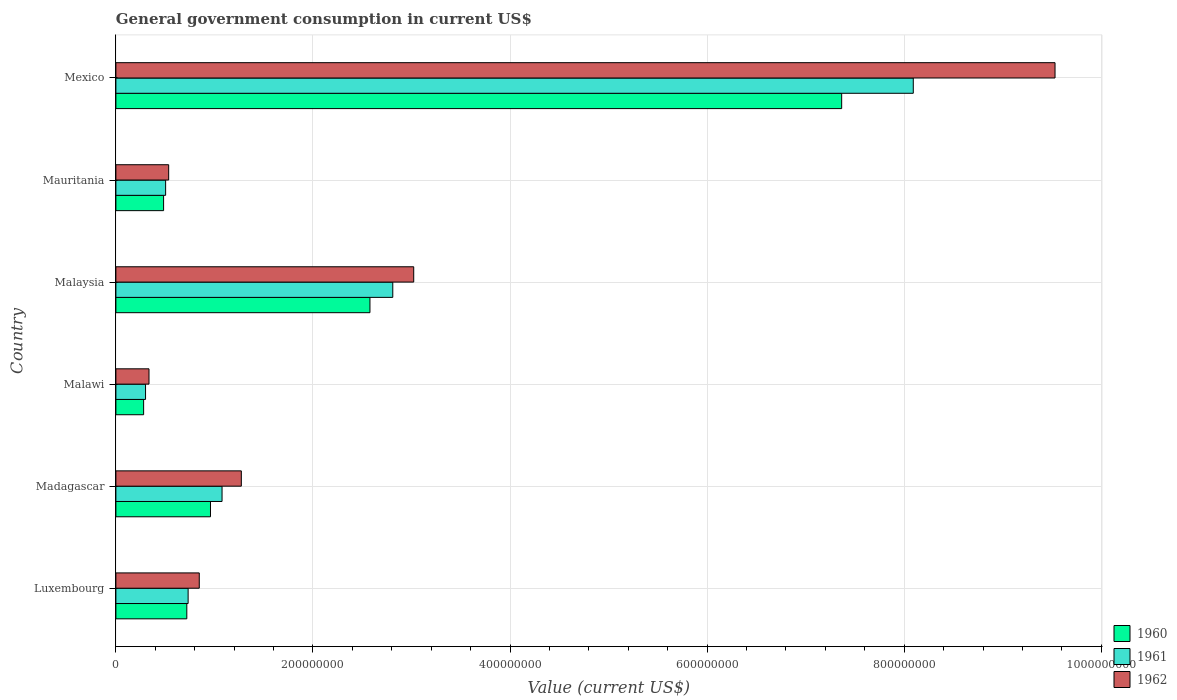How many different coloured bars are there?
Make the answer very short. 3. How many groups of bars are there?
Ensure brevity in your answer.  6. How many bars are there on the 2nd tick from the bottom?
Offer a terse response. 3. What is the label of the 5th group of bars from the top?
Offer a very short reply. Madagascar. In how many cases, is the number of bars for a given country not equal to the number of legend labels?
Your answer should be very brief. 0. What is the government conusmption in 1960 in Mexico?
Offer a terse response. 7.37e+08. Across all countries, what is the maximum government conusmption in 1962?
Your answer should be very brief. 9.53e+08. Across all countries, what is the minimum government conusmption in 1961?
Provide a short and direct response. 3.01e+07. In which country was the government conusmption in 1961 minimum?
Keep it short and to the point. Malawi. What is the total government conusmption in 1962 in the graph?
Offer a terse response. 1.55e+09. What is the difference between the government conusmption in 1961 in Malawi and that in Mexico?
Offer a terse response. -7.79e+08. What is the difference between the government conusmption in 1961 in Malaysia and the government conusmption in 1962 in Mexico?
Offer a terse response. -6.72e+08. What is the average government conusmption in 1961 per country?
Your answer should be very brief. 2.25e+08. What is the difference between the government conusmption in 1960 and government conusmption in 1962 in Mexico?
Your answer should be compact. -2.17e+08. What is the ratio of the government conusmption in 1962 in Luxembourg to that in Malawi?
Offer a terse response. 2.52. Is the government conusmption in 1962 in Luxembourg less than that in Madagascar?
Keep it short and to the point. Yes. Is the difference between the government conusmption in 1960 in Luxembourg and Malaysia greater than the difference between the government conusmption in 1962 in Luxembourg and Malaysia?
Offer a very short reply. Yes. What is the difference between the highest and the second highest government conusmption in 1962?
Give a very brief answer. 6.51e+08. What is the difference between the highest and the lowest government conusmption in 1961?
Provide a succinct answer. 7.79e+08. What does the 2nd bar from the top in Malawi represents?
Offer a terse response. 1961. Is it the case that in every country, the sum of the government conusmption in 1961 and government conusmption in 1960 is greater than the government conusmption in 1962?
Make the answer very short. Yes. How many bars are there?
Your answer should be compact. 18. How many countries are there in the graph?
Keep it short and to the point. 6. What is the difference between two consecutive major ticks on the X-axis?
Ensure brevity in your answer.  2.00e+08. Are the values on the major ticks of X-axis written in scientific E-notation?
Offer a very short reply. No. Does the graph contain any zero values?
Give a very brief answer. No. Where does the legend appear in the graph?
Offer a terse response. Bottom right. How are the legend labels stacked?
Offer a very short reply. Vertical. What is the title of the graph?
Keep it short and to the point. General government consumption in current US$. Does "1977" appear as one of the legend labels in the graph?
Your response must be concise. No. What is the label or title of the X-axis?
Offer a very short reply. Value (current US$). What is the label or title of the Y-axis?
Your response must be concise. Country. What is the Value (current US$) in 1960 in Luxembourg?
Ensure brevity in your answer.  7.20e+07. What is the Value (current US$) of 1961 in Luxembourg?
Ensure brevity in your answer.  7.33e+07. What is the Value (current US$) in 1962 in Luxembourg?
Ensure brevity in your answer.  8.46e+07. What is the Value (current US$) in 1960 in Madagascar?
Provide a succinct answer. 9.60e+07. What is the Value (current US$) in 1961 in Madagascar?
Provide a succinct answer. 1.08e+08. What is the Value (current US$) of 1962 in Madagascar?
Offer a very short reply. 1.27e+08. What is the Value (current US$) of 1960 in Malawi?
Offer a terse response. 2.81e+07. What is the Value (current US$) in 1961 in Malawi?
Give a very brief answer. 3.01e+07. What is the Value (current US$) in 1962 in Malawi?
Keep it short and to the point. 3.36e+07. What is the Value (current US$) of 1960 in Malaysia?
Your answer should be compact. 2.58e+08. What is the Value (current US$) of 1961 in Malaysia?
Offer a terse response. 2.81e+08. What is the Value (current US$) of 1962 in Malaysia?
Your response must be concise. 3.02e+08. What is the Value (current US$) in 1960 in Mauritania?
Offer a terse response. 4.84e+07. What is the Value (current US$) of 1961 in Mauritania?
Keep it short and to the point. 5.05e+07. What is the Value (current US$) of 1962 in Mauritania?
Offer a terse response. 5.36e+07. What is the Value (current US$) in 1960 in Mexico?
Give a very brief answer. 7.37e+08. What is the Value (current US$) in 1961 in Mexico?
Your response must be concise. 8.09e+08. What is the Value (current US$) of 1962 in Mexico?
Give a very brief answer. 9.53e+08. Across all countries, what is the maximum Value (current US$) of 1960?
Your answer should be compact. 7.37e+08. Across all countries, what is the maximum Value (current US$) of 1961?
Provide a short and direct response. 8.09e+08. Across all countries, what is the maximum Value (current US$) in 1962?
Your answer should be very brief. 9.53e+08. Across all countries, what is the minimum Value (current US$) in 1960?
Your answer should be very brief. 2.81e+07. Across all countries, what is the minimum Value (current US$) of 1961?
Offer a terse response. 3.01e+07. Across all countries, what is the minimum Value (current US$) in 1962?
Your response must be concise. 3.36e+07. What is the total Value (current US$) in 1960 in the graph?
Provide a succinct answer. 1.24e+09. What is the total Value (current US$) of 1961 in the graph?
Your response must be concise. 1.35e+09. What is the total Value (current US$) of 1962 in the graph?
Provide a short and direct response. 1.55e+09. What is the difference between the Value (current US$) in 1960 in Luxembourg and that in Madagascar?
Your response must be concise. -2.40e+07. What is the difference between the Value (current US$) of 1961 in Luxembourg and that in Madagascar?
Ensure brevity in your answer.  -3.44e+07. What is the difference between the Value (current US$) in 1962 in Luxembourg and that in Madagascar?
Your response must be concise. -4.27e+07. What is the difference between the Value (current US$) of 1960 in Luxembourg and that in Malawi?
Give a very brief answer. 4.38e+07. What is the difference between the Value (current US$) in 1961 in Luxembourg and that in Malawi?
Offer a very short reply. 4.32e+07. What is the difference between the Value (current US$) in 1962 in Luxembourg and that in Malawi?
Offer a terse response. 5.10e+07. What is the difference between the Value (current US$) of 1960 in Luxembourg and that in Malaysia?
Offer a very short reply. -1.86e+08. What is the difference between the Value (current US$) of 1961 in Luxembourg and that in Malaysia?
Provide a short and direct response. -2.08e+08. What is the difference between the Value (current US$) of 1962 in Luxembourg and that in Malaysia?
Give a very brief answer. -2.18e+08. What is the difference between the Value (current US$) in 1960 in Luxembourg and that in Mauritania?
Provide a short and direct response. 2.36e+07. What is the difference between the Value (current US$) of 1961 in Luxembourg and that in Mauritania?
Provide a succinct answer. 2.28e+07. What is the difference between the Value (current US$) in 1962 in Luxembourg and that in Mauritania?
Your response must be concise. 3.11e+07. What is the difference between the Value (current US$) of 1960 in Luxembourg and that in Mexico?
Offer a terse response. -6.65e+08. What is the difference between the Value (current US$) in 1961 in Luxembourg and that in Mexico?
Make the answer very short. -7.36e+08. What is the difference between the Value (current US$) in 1962 in Luxembourg and that in Mexico?
Offer a very short reply. -8.68e+08. What is the difference between the Value (current US$) of 1960 in Madagascar and that in Malawi?
Make the answer very short. 6.79e+07. What is the difference between the Value (current US$) of 1961 in Madagascar and that in Malawi?
Provide a succinct answer. 7.76e+07. What is the difference between the Value (current US$) of 1962 in Madagascar and that in Malawi?
Offer a terse response. 9.37e+07. What is the difference between the Value (current US$) of 1960 in Madagascar and that in Malaysia?
Offer a terse response. -1.62e+08. What is the difference between the Value (current US$) of 1961 in Madagascar and that in Malaysia?
Provide a short and direct response. -1.73e+08. What is the difference between the Value (current US$) of 1962 in Madagascar and that in Malaysia?
Provide a short and direct response. -1.75e+08. What is the difference between the Value (current US$) in 1960 in Madagascar and that in Mauritania?
Keep it short and to the point. 4.76e+07. What is the difference between the Value (current US$) of 1961 in Madagascar and that in Mauritania?
Your answer should be very brief. 5.73e+07. What is the difference between the Value (current US$) in 1962 in Madagascar and that in Mauritania?
Offer a very short reply. 7.37e+07. What is the difference between the Value (current US$) of 1960 in Madagascar and that in Mexico?
Ensure brevity in your answer.  -6.41e+08. What is the difference between the Value (current US$) in 1961 in Madagascar and that in Mexico?
Provide a succinct answer. -7.01e+08. What is the difference between the Value (current US$) of 1962 in Madagascar and that in Mexico?
Your answer should be compact. -8.26e+08. What is the difference between the Value (current US$) in 1960 in Malawi and that in Malaysia?
Make the answer very short. -2.30e+08. What is the difference between the Value (current US$) of 1961 in Malawi and that in Malaysia?
Ensure brevity in your answer.  -2.51e+08. What is the difference between the Value (current US$) in 1962 in Malawi and that in Malaysia?
Ensure brevity in your answer.  -2.69e+08. What is the difference between the Value (current US$) of 1960 in Malawi and that in Mauritania?
Provide a short and direct response. -2.03e+07. What is the difference between the Value (current US$) in 1961 in Malawi and that in Mauritania?
Keep it short and to the point. -2.04e+07. What is the difference between the Value (current US$) of 1962 in Malawi and that in Mauritania?
Ensure brevity in your answer.  -2.00e+07. What is the difference between the Value (current US$) in 1960 in Malawi and that in Mexico?
Ensure brevity in your answer.  -7.08e+08. What is the difference between the Value (current US$) of 1961 in Malawi and that in Mexico?
Offer a terse response. -7.79e+08. What is the difference between the Value (current US$) in 1962 in Malawi and that in Mexico?
Provide a succinct answer. -9.19e+08. What is the difference between the Value (current US$) of 1960 in Malaysia and that in Mauritania?
Provide a succinct answer. 2.09e+08. What is the difference between the Value (current US$) of 1961 in Malaysia and that in Mauritania?
Offer a very short reply. 2.31e+08. What is the difference between the Value (current US$) of 1962 in Malaysia and that in Mauritania?
Give a very brief answer. 2.49e+08. What is the difference between the Value (current US$) of 1960 in Malaysia and that in Mexico?
Offer a very short reply. -4.79e+08. What is the difference between the Value (current US$) in 1961 in Malaysia and that in Mexico?
Provide a succinct answer. -5.28e+08. What is the difference between the Value (current US$) in 1962 in Malaysia and that in Mexico?
Your answer should be very brief. -6.51e+08. What is the difference between the Value (current US$) of 1960 in Mauritania and that in Mexico?
Offer a terse response. -6.88e+08. What is the difference between the Value (current US$) of 1961 in Mauritania and that in Mexico?
Provide a succinct answer. -7.59e+08. What is the difference between the Value (current US$) of 1962 in Mauritania and that in Mexico?
Offer a very short reply. -9.00e+08. What is the difference between the Value (current US$) of 1960 in Luxembourg and the Value (current US$) of 1961 in Madagascar?
Your answer should be very brief. -3.58e+07. What is the difference between the Value (current US$) in 1960 in Luxembourg and the Value (current US$) in 1962 in Madagascar?
Your answer should be very brief. -5.53e+07. What is the difference between the Value (current US$) of 1961 in Luxembourg and the Value (current US$) of 1962 in Madagascar?
Provide a succinct answer. -5.40e+07. What is the difference between the Value (current US$) in 1960 in Luxembourg and the Value (current US$) in 1961 in Malawi?
Your answer should be very brief. 4.19e+07. What is the difference between the Value (current US$) of 1960 in Luxembourg and the Value (current US$) of 1962 in Malawi?
Your response must be concise. 3.84e+07. What is the difference between the Value (current US$) of 1961 in Luxembourg and the Value (current US$) of 1962 in Malawi?
Your answer should be compact. 3.97e+07. What is the difference between the Value (current US$) in 1960 in Luxembourg and the Value (current US$) in 1961 in Malaysia?
Your response must be concise. -2.09e+08. What is the difference between the Value (current US$) in 1960 in Luxembourg and the Value (current US$) in 1962 in Malaysia?
Offer a very short reply. -2.30e+08. What is the difference between the Value (current US$) of 1961 in Luxembourg and the Value (current US$) of 1962 in Malaysia?
Your answer should be very brief. -2.29e+08. What is the difference between the Value (current US$) of 1960 in Luxembourg and the Value (current US$) of 1961 in Mauritania?
Provide a succinct answer. 2.15e+07. What is the difference between the Value (current US$) in 1960 in Luxembourg and the Value (current US$) in 1962 in Mauritania?
Keep it short and to the point. 1.84e+07. What is the difference between the Value (current US$) in 1961 in Luxembourg and the Value (current US$) in 1962 in Mauritania?
Give a very brief answer. 1.97e+07. What is the difference between the Value (current US$) of 1960 in Luxembourg and the Value (current US$) of 1961 in Mexico?
Ensure brevity in your answer.  -7.37e+08. What is the difference between the Value (current US$) of 1960 in Luxembourg and the Value (current US$) of 1962 in Mexico?
Keep it short and to the point. -8.81e+08. What is the difference between the Value (current US$) in 1961 in Luxembourg and the Value (current US$) in 1962 in Mexico?
Your answer should be compact. -8.80e+08. What is the difference between the Value (current US$) of 1960 in Madagascar and the Value (current US$) of 1961 in Malawi?
Keep it short and to the point. 6.59e+07. What is the difference between the Value (current US$) in 1960 in Madagascar and the Value (current US$) in 1962 in Malawi?
Give a very brief answer. 6.24e+07. What is the difference between the Value (current US$) in 1961 in Madagascar and the Value (current US$) in 1962 in Malawi?
Offer a terse response. 7.41e+07. What is the difference between the Value (current US$) of 1960 in Madagascar and the Value (current US$) of 1961 in Malaysia?
Make the answer very short. -1.85e+08. What is the difference between the Value (current US$) of 1960 in Madagascar and the Value (current US$) of 1962 in Malaysia?
Your response must be concise. -2.06e+08. What is the difference between the Value (current US$) of 1961 in Madagascar and the Value (current US$) of 1962 in Malaysia?
Offer a terse response. -1.95e+08. What is the difference between the Value (current US$) in 1960 in Madagascar and the Value (current US$) in 1961 in Mauritania?
Your answer should be compact. 4.55e+07. What is the difference between the Value (current US$) in 1960 in Madagascar and the Value (current US$) in 1962 in Mauritania?
Your answer should be compact. 4.24e+07. What is the difference between the Value (current US$) in 1961 in Madagascar and the Value (current US$) in 1962 in Mauritania?
Your answer should be compact. 5.42e+07. What is the difference between the Value (current US$) of 1960 in Madagascar and the Value (current US$) of 1961 in Mexico?
Offer a very short reply. -7.13e+08. What is the difference between the Value (current US$) of 1960 in Madagascar and the Value (current US$) of 1962 in Mexico?
Your answer should be compact. -8.57e+08. What is the difference between the Value (current US$) of 1961 in Madagascar and the Value (current US$) of 1962 in Mexico?
Keep it short and to the point. -8.45e+08. What is the difference between the Value (current US$) in 1960 in Malawi and the Value (current US$) in 1961 in Malaysia?
Offer a very short reply. -2.53e+08. What is the difference between the Value (current US$) of 1960 in Malawi and the Value (current US$) of 1962 in Malaysia?
Your response must be concise. -2.74e+08. What is the difference between the Value (current US$) of 1961 in Malawi and the Value (current US$) of 1962 in Malaysia?
Your answer should be compact. -2.72e+08. What is the difference between the Value (current US$) in 1960 in Malawi and the Value (current US$) in 1961 in Mauritania?
Provide a short and direct response. -2.23e+07. What is the difference between the Value (current US$) in 1960 in Malawi and the Value (current US$) in 1962 in Mauritania?
Offer a very short reply. -2.54e+07. What is the difference between the Value (current US$) in 1961 in Malawi and the Value (current US$) in 1962 in Mauritania?
Provide a short and direct response. -2.35e+07. What is the difference between the Value (current US$) of 1960 in Malawi and the Value (current US$) of 1961 in Mexico?
Give a very brief answer. -7.81e+08. What is the difference between the Value (current US$) in 1960 in Malawi and the Value (current US$) in 1962 in Mexico?
Provide a succinct answer. -9.25e+08. What is the difference between the Value (current US$) of 1961 in Malawi and the Value (current US$) of 1962 in Mexico?
Keep it short and to the point. -9.23e+08. What is the difference between the Value (current US$) in 1960 in Malaysia and the Value (current US$) in 1961 in Mauritania?
Provide a succinct answer. 2.07e+08. What is the difference between the Value (current US$) of 1960 in Malaysia and the Value (current US$) of 1962 in Mauritania?
Make the answer very short. 2.04e+08. What is the difference between the Value (current US$) of 1961 in Malaysia and the Value (current US$) of 1962 in Mauritania?
Your answer should be compact. 2.27e+08. What is the difference between the Value (current US$) of 1960 in Malaysia and the Value (current US$) of 1961 in Mexico?
Ensure brevity in your answer.  -5.51e+08. What is the difference between the Value (current US$) in 1960 in Malaysia and the Value (current US$) in 1962 in Mexico?
Offer a very short reply. -6.95e+08. What is the difference between the Value (current US$) in 1961 in Malaysia and the Value (current US$) in 1962 in Mexico?
Your response must be concise. -6.72e+08. What is the difference between the Value (current US$) in 1960 in Mauritania and the Value (current US$) in 1961 in Mexico?
Ensure brevity in your answer.  -7.61e+08. What is the difference between the Value (current US$) in 1960 in Mauritania and the Value (current US$) in 1962 in Mexico?
Keep it short and to the point. -9.05e+08. What is the difference between the Value (current US$) of 1961 in Mauritania and the Value (current US$) of 1962 in Mexico?
Offer a terse response. -9.03e+08. What is the average Value (current US$) of 1960 per country?
Provide a succinct answer. 2.06e+08. What is the average Value (current US$) of 1961 per country?
Your response must be concise. 2.25e+08. What is the average Value (current US$) in 1962 per country?
Ensure brevity in your answer.  2.59e+08. What is the difference between the Value (current US$) of 1960 and Value (current US$) of 1961 in Luxembourg?
Your response must be concise. -1.33e+06. What is the difference between the Value (current US$) of 1960 and Value (current US$) of 1962 in Luxembourg?
Make the answer very short. -1.26e+07. What is the difference between the Value (current US$) of 1961 and Value (current US$) of 1962 in Luxembourg?
Your answer should be compact. -1.13e+07. What is the difference between the Value (current US$) in 1960 and Value (current US$) in 1961 in Madagascar?
Offer a terse response. -1.17e+07. What is the difference between the Value (current US$) in 1960 and Value (current US$) in 1962 in Madagascar?
Your response must be concise. -3.13e+07. What is the difference between the Value (current US$) of 1961 and Value (current US$) of 1962 in Madagascar?
Your answer should be very brief. -1.96e+07. What is the difference between the Value (current US$) in 1960 and Value (current US$) in 1961 in Malawi?
Keep it short and to the point. -1.96e+06. What is the difference between the Value (current US$) of 1960 and Value (current US$) of 1962 in Malawi?
Provide a short and direct response. -5.46e+06. What is the difference between the Value (current US$) of 1961 and Value (current US$) of 1962 in Malawi?
Ensure brevity in your answer.  -3.50e+06. What is the difference between the Value (current US$) in 1960 and Value (current US$) in 1961 in Malaysia?
Your response must be concise. -2.32e+07. What is the difference between the Value (current US$) of 1960 and Value (current US$) of 1962 in Malaysia?
Offer a very short reply. -4.44e+07. What is the difference between the Value (current US$) in 1961 and Value (current US$) in 1962 in Malaysia?
Give a very brief answer. -2.12e+07. What is the difference between the Value (current US$) in 1960 and Value (current US$) in 1961 in Mauritania?
Offer a terse response. -2.06e+06. What is the difference between the Value (current US$) in 1960 and Value (current US$) in 1962 in Mauritania?
Provide a short and direct response. -5.15e+06. What is the difference between the Value (current US$) in 1961 and Value (current US$) in 1962 in Mauritania?
Your answer should be very brief. -3.09e+06. What is the difference between the Value (current US$) in 1960 and Value (current US$) in 1961 in Mexico?
Keep it short and to the point. -7.27e+07. What is the difference between the Value (current US$) in 1960 and Value (current US$) in 1962 in Mexico?
Offer a terse response. -2.17e+08. What is the difference between the Value (current US$) of 1961 and Value (current US$) of 1962 in Mexico?
Give a very brief answer. -1.44e+08. What is the ratio of the Value (current US$) of 1960 in Luxembourg to that in Madagascar?
Your answer should be very brief. 0.75. What is the ratio of the Value (current US$) in 1961 in Luxembourg to that in Madagascar?
Your answer should be compact. 0.68. What is the ratio of the Value (current US$) of 1962 in Luxembourg to that in Madagascar?
Give a very brief answer. 0.66. What is the ratio of the Value (current US$) of 1960 in Luxembourg to that in Malawi?
Make the answer very short. 2.56. What is the ratio of the Value (current US$) of 1961 in Luxembourg to that in Malawi?
Provide a succinct answer. 2.44. What is the ratio of the Value (current US$) of 1962 in Luxembourg to that in Malawi?
Offer a very short reply. 2.52. What is the ratio of the Value (current US$) of 1960 in Luxembourg to that in Malaysia?
Your answer should be compact. 0.28. What is the ratio of the Value (current US$) of 1961 in Luxembourg to that in Malaysia?
Offer a very short reply. 0.26. What is the ratio of the Value (current US$) in 1962 in Luxembourg to that in Malaysia?
Your answer should be very brief. 0.28. What is the ratio of the Value (current US$) in 1960 in Luxembourg to that in Mauritania?
Keep it short and to the point. 1.49. What is the ratio of the Value (current US$) of 1961 in Luxembourg to that in Mauritania?
Keep it short and to the point. 1.45. What is the ratio of the Value (current US$) in 1962 in Luxembourg to that in Mauritania?
Your response must be concise. 1.58. What is the ratio of the Value (current US$) in 1960 in Luxembourg to that in Mexico?
Your response must be concise. 0.1. What is the ratio of the Value (current US$) of 1961 in Luxembourg to that in Mexico?
Offer a terse response. 0.09. What is the ratio of the Value (current US$) in 1962 in Luxembourg to that in Mexico?
Give a very brief answer. 0.09. What is the ratio of the Value (current US$) in 1960 in Madagascar to that in Malawi?
Give a very brief answer. 3.41. What is the ratio of the Value (current US$) in 1961 in Madagascar to that in Malawi?
Your answer should be very brief. 3.58. What is the ratio of the Value (current US$) of 1962 in Madagascar to that in Malawi?
Provide a succinct answer. 3.79. What is the ratio of the Value (current US$) in 1960 in Madagascar to that in Malaysia?
Give a very brief answer. 0.37. What is the ratio of the Value (current US$) in 1961 in Madagascar to that in Malaysia?
Make the answer very short. 0.38. What is the ratio of the Value (current US$) of 1962 in Madagascar to that in Malaysia?
Your answer should be compact. 0.42. What is the ratio of the Value (current US$) in 1960 in Madagascar to that in Mauritania?
Ensure brevity in your answer.  1.98. What is the ratio of the Value (current US$) of 1961 in Madagascar to that in Mauritania?
Ensure brevity in your answer.  2.13. What is the ratio of the Value (current US$) in 1962 in Madagascar to that in Mauritania?
Offer a terse response. 2.38. What is the ratio of the Value (current US$) of 1960 in Madagascar to that in Mexico?
Give a very brief answer. 0.13. What is the ratio of the Value (current US$) in 1961 in Madagascar to that in Mexico?
Keep it short and to the point. 0.13. What is the ratio of the Value (current US$) of 1962 in Madagascar to that in Mexico?
Offer a terse response. 0.13. What is the ratio of the Value (current US$) of 1960 in Malawi to that in Malaysia?
Your response must be concise. 0.11. What is the ratio of the Value (current US$) of 1961 in Malawi to that in Malaysia?
Your answer should be very brief. 0.11. What is the ratio of the Value (current US$) of 1962 in Malawi to that in Malaysia?
Your response must be concise. 0.11. What is the ratio of the Value (current US$) of 1960 in Malawi to that in Mauritania?
Your answer should be compact. 0.58. What is the ratio of the Value (current US$) of 1961 in Malawi to that in Mauritania?
Your answer should be very brief. 0.6. What is the ratio of the Value (current US$) in 1962 in Malawi to that in Mauritania?
Ensure brevity in your answer.  0.63. What is the ratio of the Value (current US$) of 1960 in Malawi to that in Mexico?
Your answer should be compact. 0.04. What is the ratio of the Value (current US$) of 1961 in Malawi to that in Mexico?
Your answer should be compact. 0.04. What is the ratio of the Value (current US$) of 1962 in Malawi to that in Mexico?
Give a very brief answer. 0.04. What is the ratio of the Value (current US$) in 1960 in Malaysia to that in Mauritania?
Ensure brevity in your answer.  5.33. What is the ratio of the Value (current US$) in 1961 in Malaysia to that in Mauritania?
Your answer should be very brief. 5.57. What is the ratio of the Value (current US$) in 1962 in Malaysia to that in Mauritania?
Your answer should be very brief. 5.64. What is the ratio of the Value (current US$) of 1960 in Malaysia to that in Mexico?
Your answer should be very brief. 0.35. What is the ratio of the Value (current US$) in 1961 in Malaysia to that in Mexico?
Keep it short and to the point. 0.35. What is the ratio of the Value (current US$) in 1962 in Malaysia to that in Mexico?
Your response must be concise. 0.32. What is the ratio of the Value (current US$) of 1960 in Mauritania to that in Mexico?
Keep it short and to the point. 0.07. What is the ratio of the Value (current US$) in 1961 in Mauritania to that in Mexico?
Give a very brief answer. 0.06. What is the ratio of the Value (current US$) in 1962 in Mauritania to that in Mexico?
Ensure brevity in your answer.  0.06. What is the difference between the highest and the second highest Value (current US$) of 1960?
Provide a short and direct response. 4.79e+08. What is the difference between the highest and the second highest Value (current US$) in 1961?
Provide a short and direct response. 5.28e+08. What is the difference between the highest and the second highest Value (current US$) in 1962?
Your answer should be compact. 6.51e+08. What is the difference between the highest and the lowest Value (current US$) of 1960?
Offer a terse response. 7.08e+08. What is the difference between the highest and the lowest Value (current US$) in 1961?
Ensure brevity in your answer.  7.79e+08. What is the difference between the highest and the lowest Value (current US$) in 1962?
Ensure brevity in your answer.  9.19e+08. 